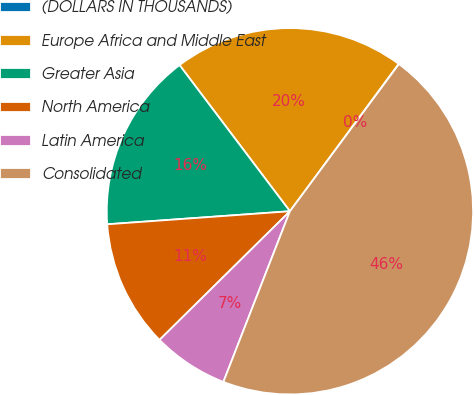Convert chart to OTSL. <chart><loc_0><loc_0><loc_500><loc_500><pie_chart><fcel>(DOLLARS IN THOUSANDS)<fcel>Europe Africa and Middle East<fcel>Greater Asia<fcel>North America<fcel>Latin America<fcel>Consolidated<nl><fcel>0.03%<fcel>20.41%<fcel>15.84%<fcel>11.26%<fcel>6.69%<fcel>45.77%<nl></chart> 